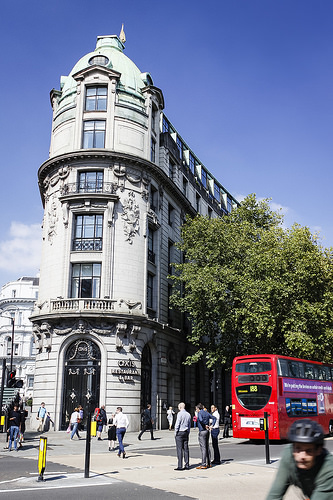<image>
Can you confirm if the bus is under the building? No. The bus is not positioned under the building. The vertical relationship between these objects is different. 